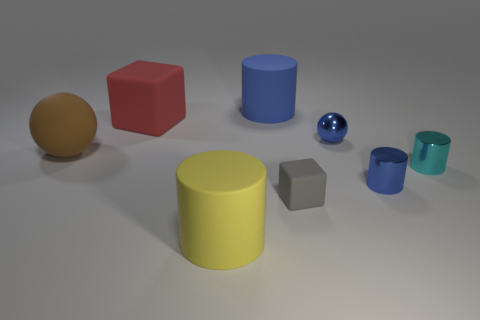There is a big object that is right of the large red cube and to the left of the large blue rubber cylinder; what material is it?
Offer a terse response. Rubber. What number of other tiny gray objects are the same shape as the gray object?
Keep it short and to the point. 0. There is a block that is left of the cylinder that is in front of the cube that is right of the big yellow cylinder; what is its size?
Ensure brevity in your answer.  Large. Are there more yellow things that are behind the tiny blue metallic sphere than green matte objects?
Give a very brief answer. No. Is there a small cyan matte cube?
Keep it short and to the point. No. How many yellow matte things are the same size as the red rubber thing?
Ensure brevity in your answer.  1. Is the number of blue metallic cylinders that are behind the small blue metallic cylinder greater than the number of blue things that are behind the large brown matte sphere?
Your response must be concise. No. There is a red block that is the same size as the yellow matte cylinder; what material is it?
Offer a very short reply. Rubber. There is a small gray rubber object; what shape is it?
Make the answer very short. Cube. What number of gray objects are either small balls or shiny objects?
Provide a short and direct response. 0. 